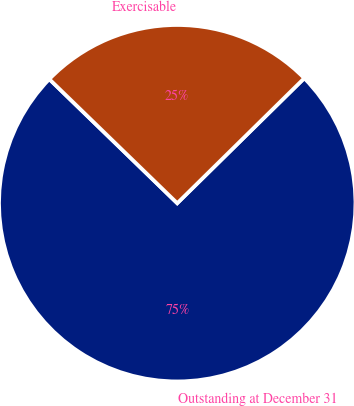Convert chart to OTSL. <chart><loc_0><loc_0><loc_500><loc_500><pie_chart><fcel>Outstanding at December 31<fcel>Exercisable<nl><fcel>74.63%<fcel>25.37%<nl></chart> 